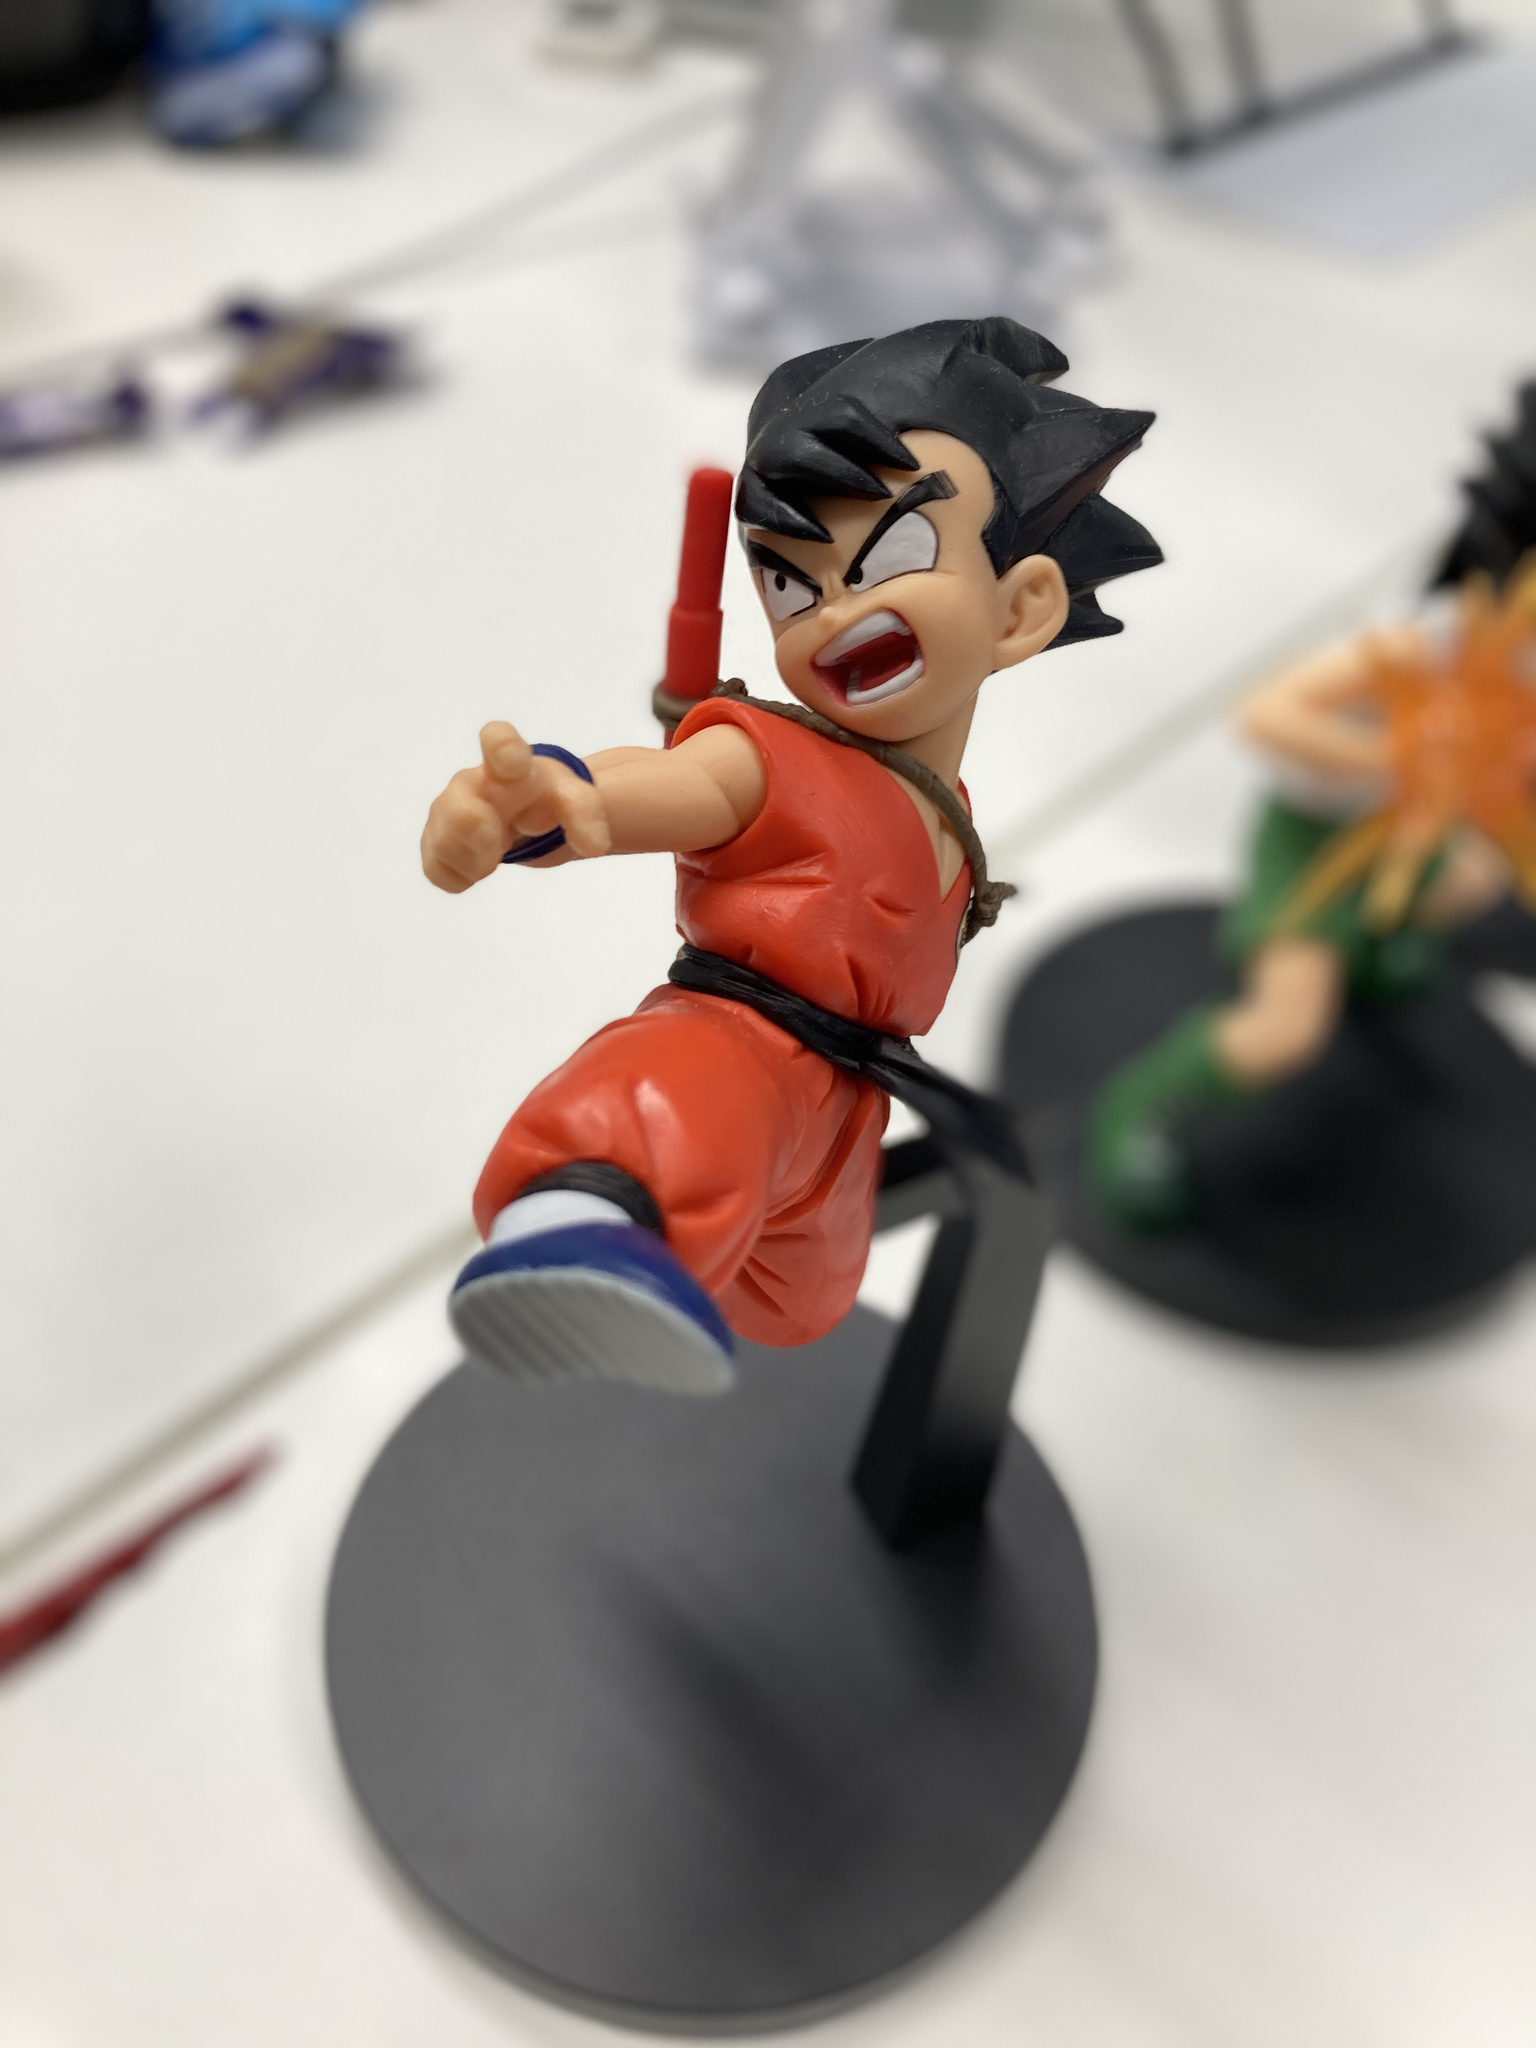这是什么动漫人物 这是动漫《龙珠》中的角色孙悟空（幼年时期）。他是由鸟山明创作的经典角色，以他强大的战斗力和正义感著称。 